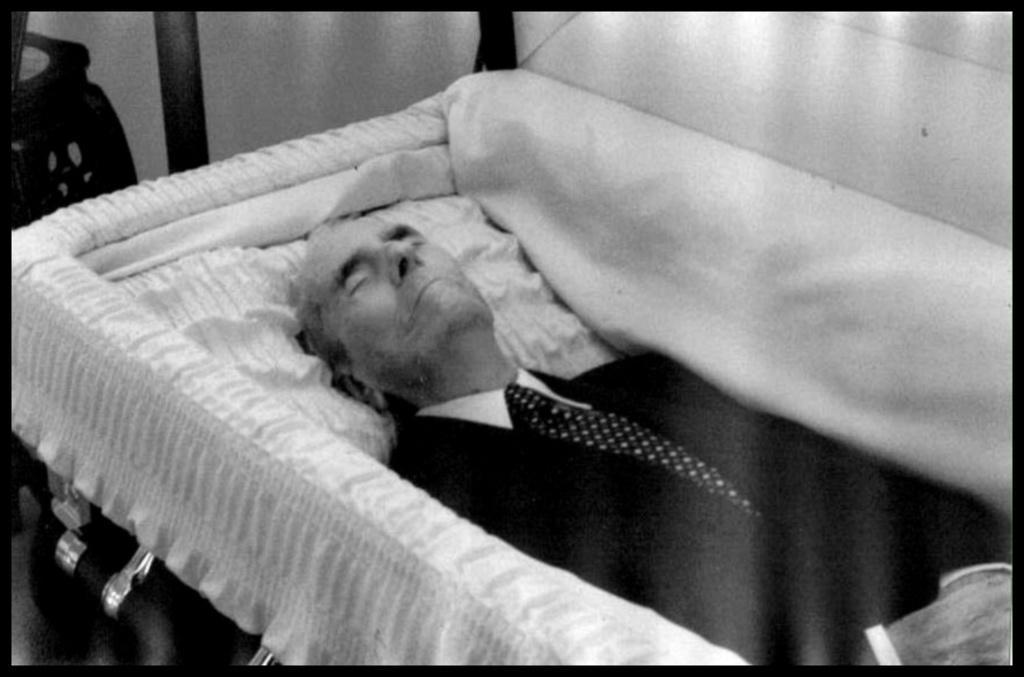Describe this image in one or two sentences. This is a black and white picture. The old man in white shirt and black blazer is in the casket. Behind him, we see a wall. 